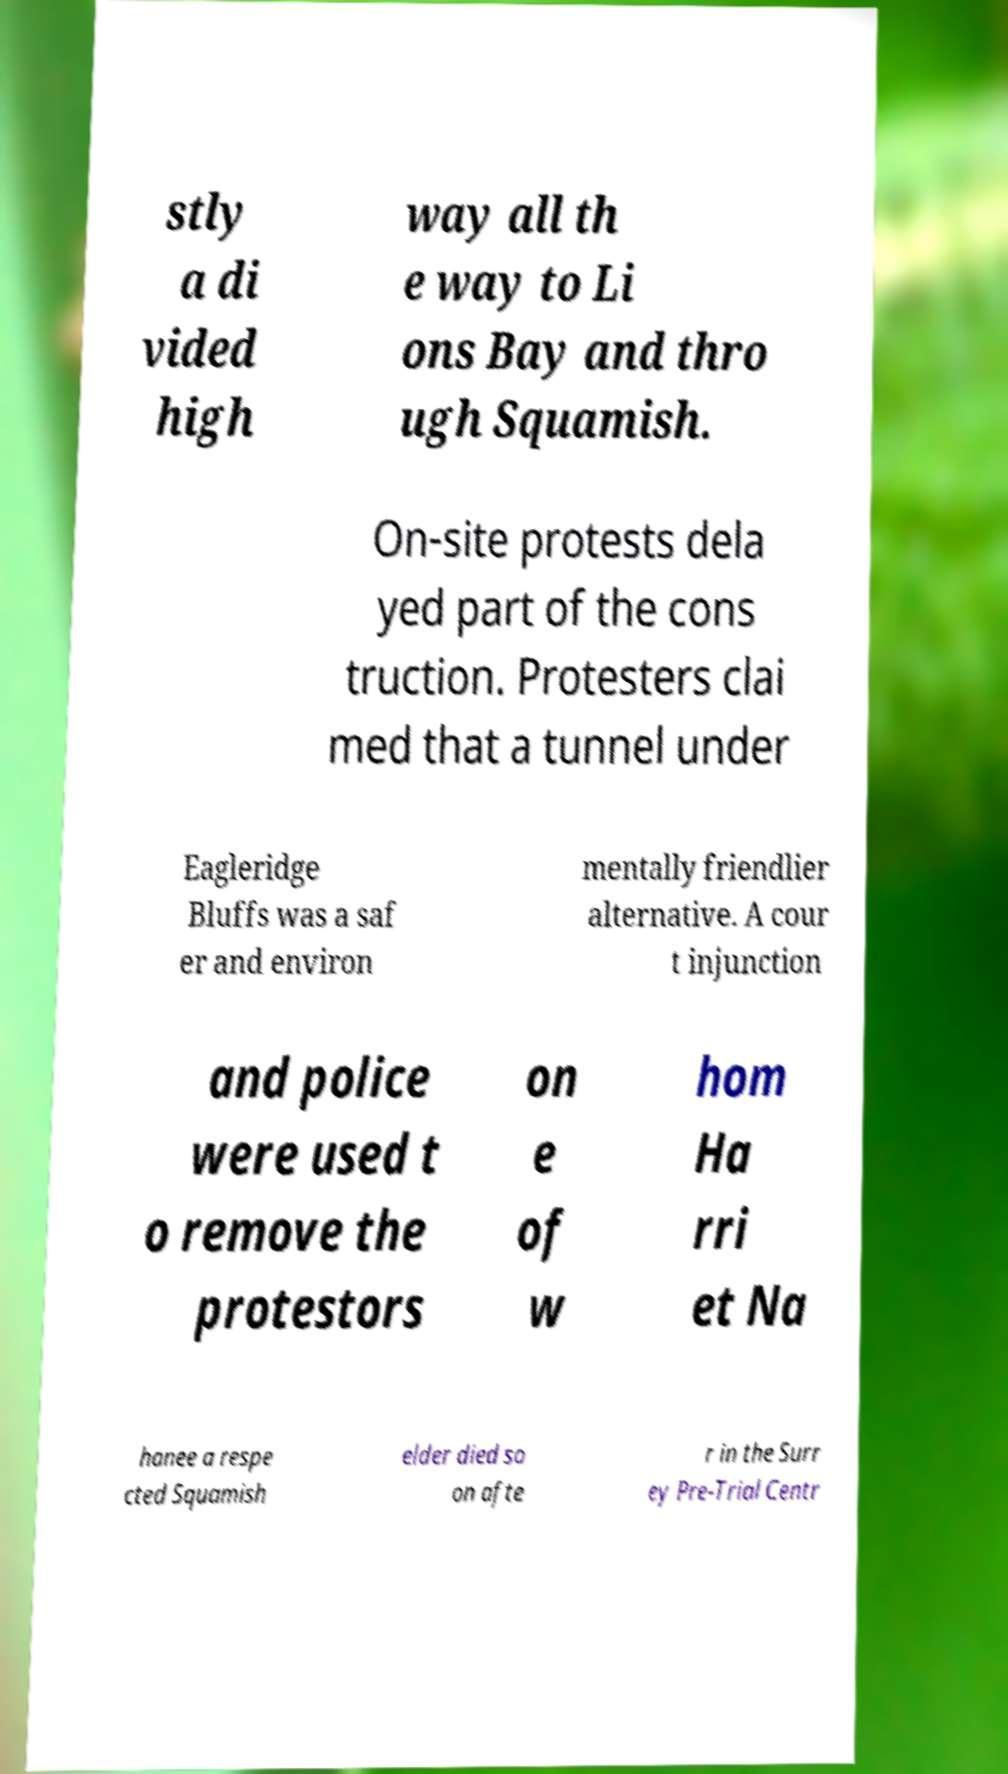What messages or text are displayed in this image? I need them in a readable, typed format. stly a di vided high way all th e way to Li ons Bay and thro ugh Squamish. On-site protests dela yed part of the cons truction. Protesters clai med that a tunnel under Eagleridge Bluffs was a saf er and environ mentally friendlier alternative. A cour t injunction and police were used t o remove the protestors on e of w hom Ha rri et Na hanee a respe cted Squamish elder died so on afte r in the Surr ey Pre-Trial Centr 